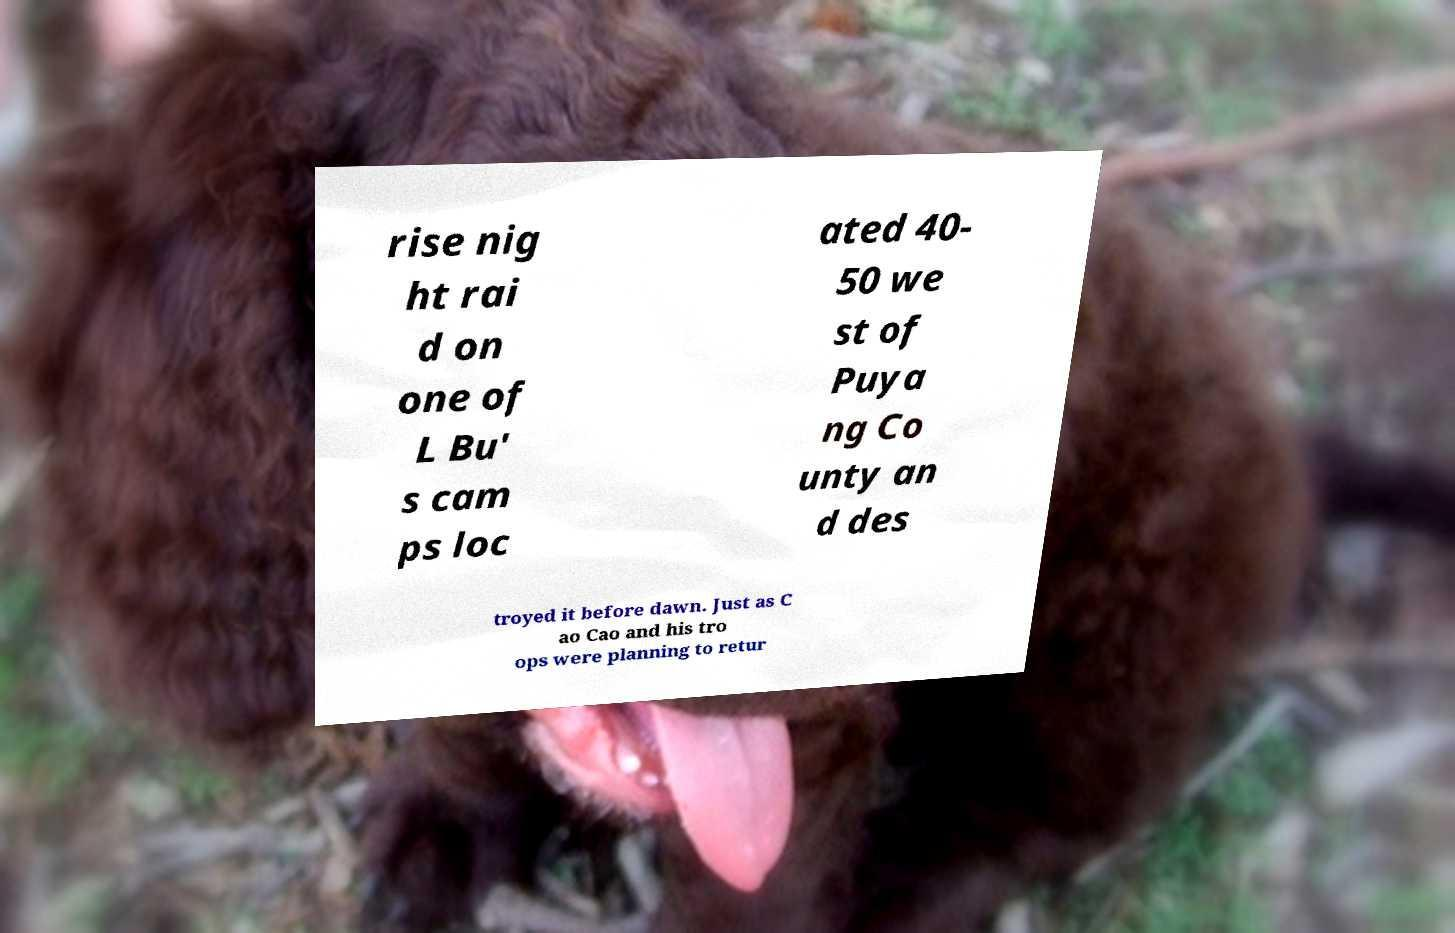I need the written content from this picture converted into text. Can you do that? rise nig ht rai d on one of L Bu' s cam ps loc ated 40- 50 we st of Puya ng Co unty an d des troyed it before dawn. Just as C ao Cao and his tro ops were planning to retur 